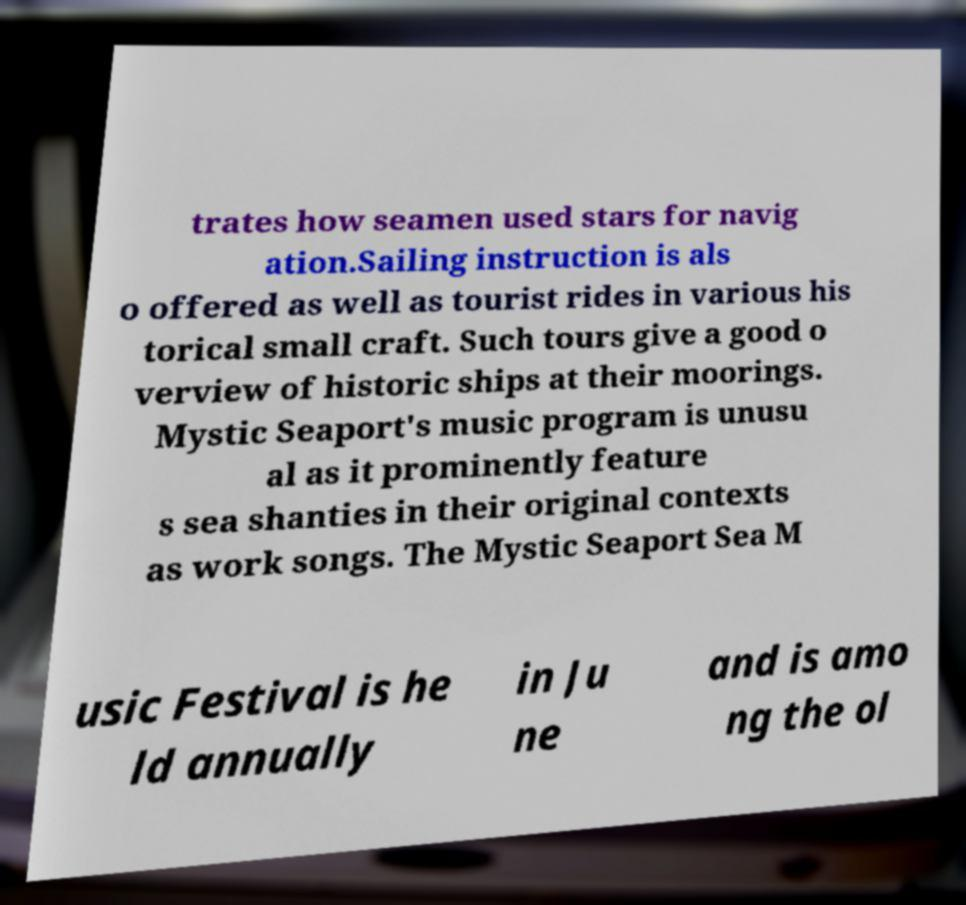What messages or text are displayed in this image? I need them in a readable, typed format. trates how seamen used stars for navig ation.Sailing instruction is als o offered as well as tourist rides in various his torical small craft. Such tours give a good o verview of historic ships at their moorings. Mystic Seaport's music program is unusu al as it prominently feature s sea shanties in their original contexts as work songs. The Mystic Seaport Sea M usic Festival is he ld annually in Ju ne and is amo ng the ol 